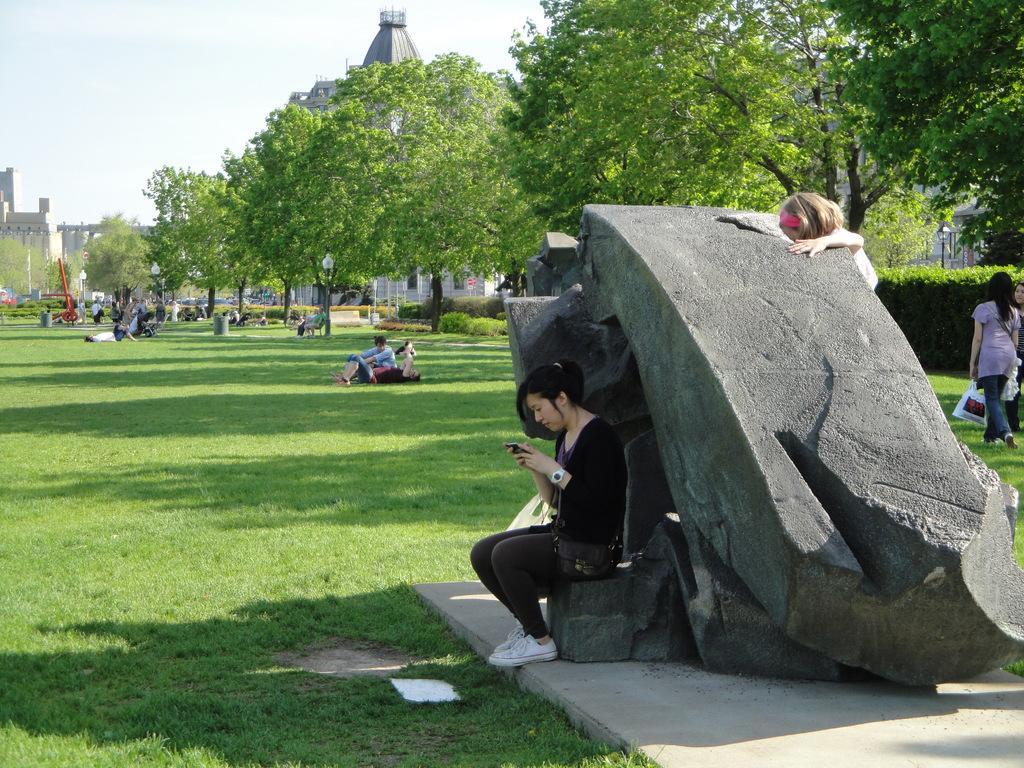Describe this image in one or two sentences. In this image in the foreground there are some people who are sitting and there is one rock, in the background there are some trees buildings and some persons are sitting on a grass. On the top of the image there is sky. 